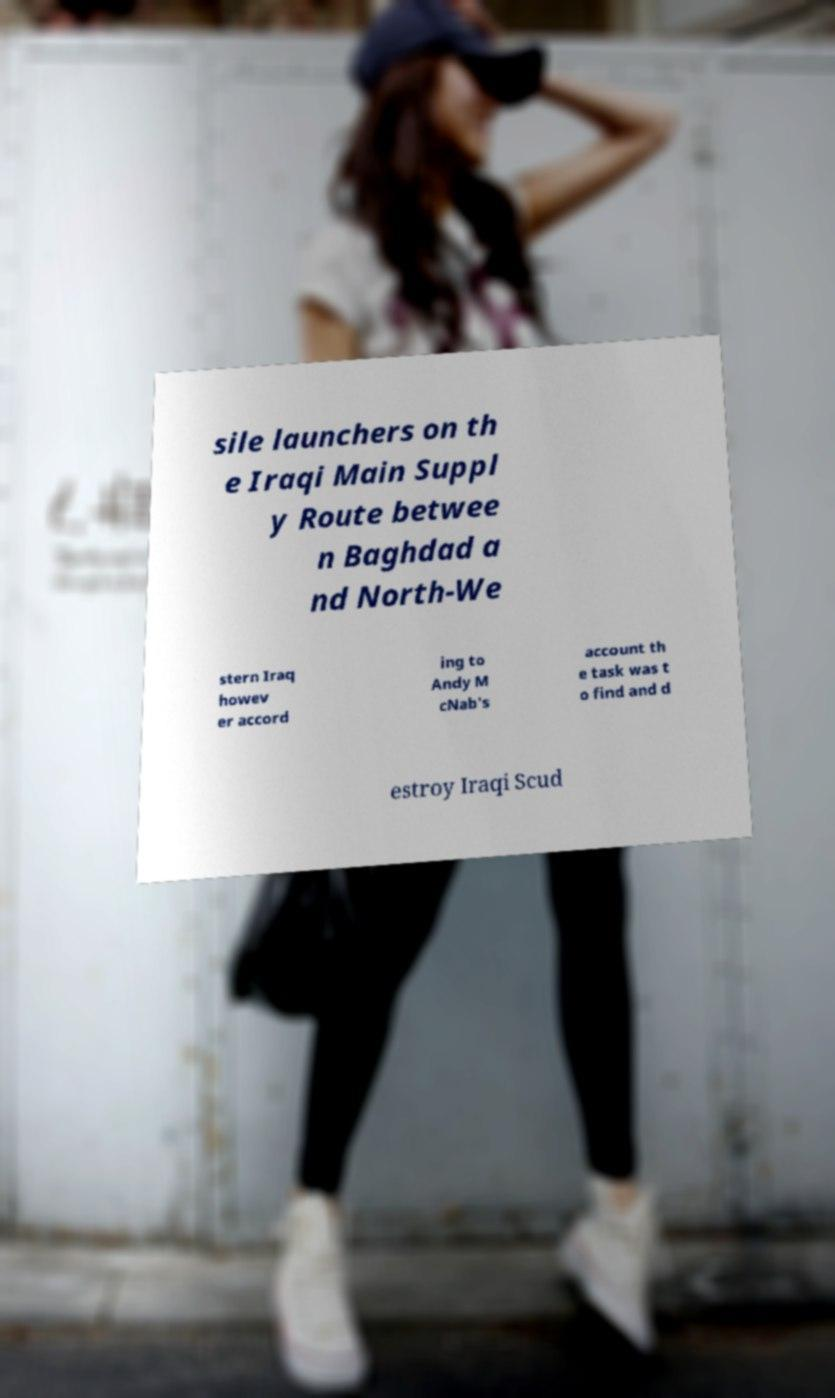Please identify and transcribe the text found in this image. sile launchers on th e Iraqi Main Suppl y Route betwee n Baghdad a nd North-We stern Iraq howev er accord ing to Andy M cNab's account th e task was t o find and d estroy Iraqi Scud 